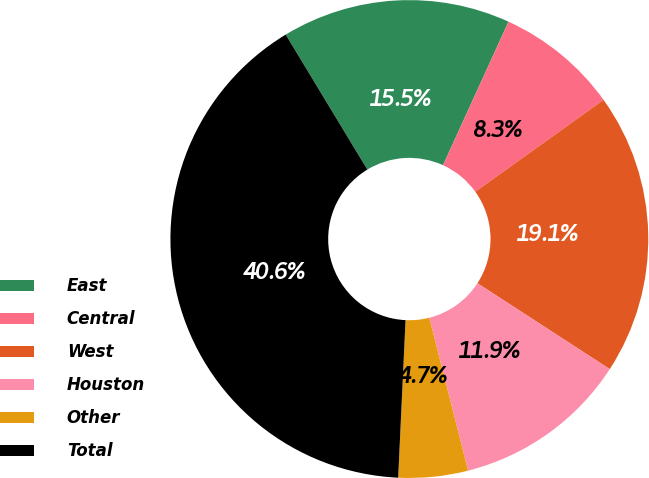Convert chart to OTSL. <chart><loc_0><loc_0><loc_500><loc_500><pie_chart><fcel>East<fcel>Central<fcel>West<fcel>Houston<fcel>Other<fcel>Total<nl><fcel>15.47%<fcel>8.29%<fcel>19.06%<fcel>11.88%<fcel>4.7%<fcel>40.6%<nl></chart> 